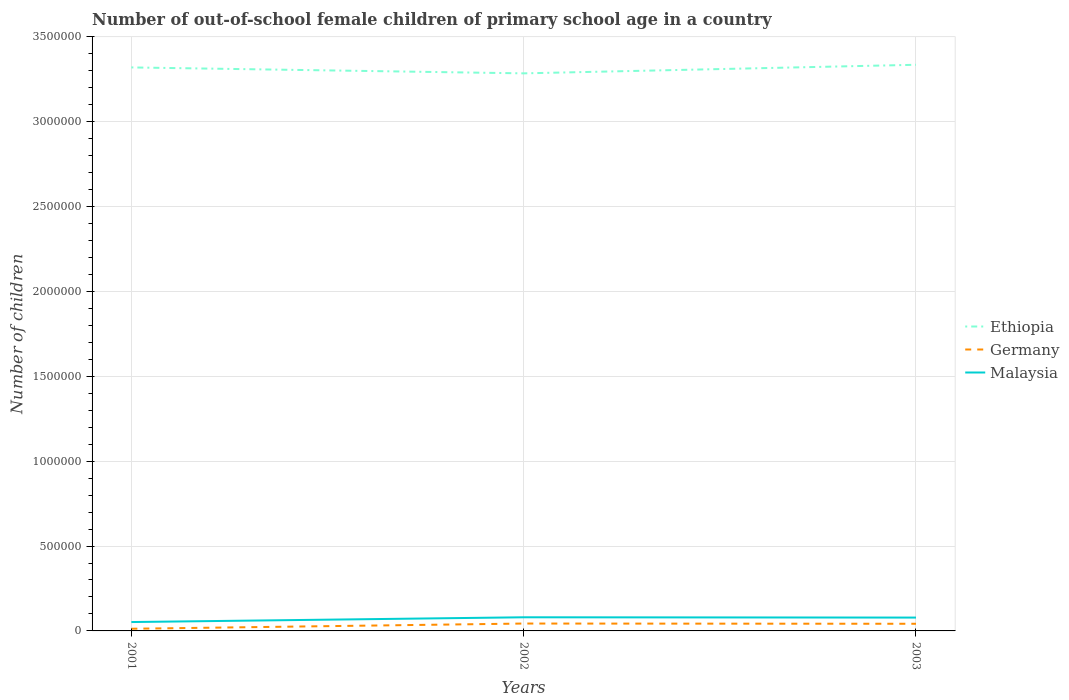How many different coloured lines are there?
Your answer should be compact. 3. Does the line corresponding to Ethiopia intersect with the line corresponding to Germany?
Provide a short and direct response. No. Is the number of lines equal to the number of legend labels?
Your response must be concise. Yes. Across all years, what is the maximum number of out-of-school female children in Germany?
Provide a succinct answer. 1.28e+04. In which year was the number of out-of-school female children in Germany maximum?
Provide a short and direct response. 2001. What is the total number of out-of-school female children in Germany in the graph?
Make the answer very short. 1411. What is the difference between the highest and the second highest number of out-of-school female children in Germany?
Make the answer very short. 3.07e+04. What is the difference between the highest and the lowest number of out-of-school female children in Ethiopia?
Make the answer very short. 2. Is the number of out-of-school female children in Ethiopia strictly greater than the number of out-of-school female children in Malaysia over the years?
Provide a short and direct response. No. Where does the legend appear in the graph?
Your answer should be very brief. Center right. What is the title of the graph?
Offer a very short reply. Number of out-of-school female children of primary school age in a country. What is the label or title of the X-axis?
Offer a very short reply. Years. What is the label or title of the Y-axis?
Your answer should be very brief. Number of children. What is the Number of children in Ethiopia in 2001?
Keep it short and to the point. 3.32e+06. What is the Number of children in Germany in 2001?
Provide a short and direct response. 1.28e+04. What is the Number of children in Malaysia in 2001?
Your answer should be compact. 5.23e+04. What is the Number of children of Ethiopia in 2002?
Provide a short and direct response. 3.28e+06. What is the Number of children in Germany in 2002?
Ensure brevity in your answer.  4.35e+04. What is the Number of children of Malaysia in 2002?
Offer a terse response. 8.04e+04. What is the Number of children of Ethiopia in 2003?
Provide a succinct answer. 3.34e+06. What is the Number of children in Germany in 2003?
Ensure brevity in your answer.  4.21e+04. What is the Number of children of Malaysia in 2003?
Your answer should be compact. 7.86e+04. Across all years, what is the maximum Number of children in Ethiopia?
Provide a succinct answer. 3.34e+06. Across all years, what is the maximum Number of children in Germany?
Your response must be concise. 4.35e+04. Across all years, what is the maximum Number of children in Malaysia?
Offer a very short reply. 8.04e+04. Across all years, what is the minimum Number of children in Ethiopia?
Make the answer very short. 3.28e+06. Across all years, what is the minimum Number of children of Germany?
Keep it short and to the point. 1.28e+04. Across all years, what is the minimum Number of children in Malaysia?
Your answer should be very brief. 5.23e+04. What is the total Number of children of Ethiopia in the graph?
Give a very brief answer. 9.94e+06. What is the total Number of children in Germany in the graph?
Keep it short and to the point. 9.84e+04. What is the total Number of children in Malaysia in the graph?
Offer a terse response. 2.11e+05. What is the difference between the Number of children of Ethiopia in 2001 and that in 2002?
Keep it short and to the point. 3.50e+04. What is the difference between the Number of children of Germany in 2001 and that in 2002?
Ensure brevity in your answer.  -3.07e+04. What is the difference between the Number of children of Malaysia in 2001 and that in 2002?
Your response must be concise. -2.81e+04. What is the difference between the Number of children in Ethiopia in 2001 and that in 2003?
Your answer should be very brief. -1.56e+04. What is the difference between the Number of children in Germany in 2001 and that in 2003?
Your response must be concise. -2.93e+04. What is the difference between the Number of children in Malaysia in 2001 and that in 2003?
Provide a succinct answer. -2.63e+04. What is the difference between the Number of children of Ethiopia in 2002 and that in 2003?
Give a very brief answer. -5.06e+04. What is the difference between the Number of children in Germany in 2002 and that in 2003?
Provide a short and direct response. 1411. What is the difference between the Number of children of Malaysia in 2002 and that in 2003?
Make the answer very short. 1818. What is the difference between the Number of children of Ethiopia in 2001 and the Number of children of Germany in 2002?
Your answer should be compact. 3.28e+06. What is the difference between the Number of children in Ethiopia in 2001 and the Number of children in Malaysia in 2002?
Give a very brief answer. 3.24e+06. What is the difference between the Number of children of Germany in 2001 and the Number of children of Malaysia in 2002?
Provide a succinct answer. -6.76e+04. What is the difference between the Number of children of Ethiopia in 2001 and the Number of children of Germany in 2003?
Ensure brevity in your answer.  3.28e+06. What is the difference between the Number of children of Ethiopia in 2001 and the Number of children of Malaysia in 2003?
Provide a short and direct response. 3.24e+06. What is the difference between the Number of children in Germany in 2001 and the Number of children in Malaysia in 2003?
Your response must be concise. -6.58e+04. What is the difference between the Number of children of Ethiopia in 2002 and the Number of children of Germany in 2003?
Your answer should be very brief. 3.24e+06. What is the difference between the Number of children of Ethiopia in 2002 and the Number of children of Malaysia in 2003?
Offer a very short reply. 3.21e+06. What is the difference between the Number of children in Germany in 2002 and the Number of children in Malaysia in 2003?
Provide a short and direct response. -3.51e+04. What is the average Number of children of Ethiopia per year?
Keep it short and to the point. 3.31e+06. What is the average Number of children in Germany per year?
Your answer should be compact. 3.28e+04. What is the average Number of children of Malaysia per year?
Give a very brief answer. 7.04e+04. In the year 2001, what is the difference between the Number of children of Ethiopia and Number of children of Germany?
Your response must be concise. 3.31e+06. In the year 2001, what is the difference between the Number of children of Ethiopia and Number of children of Malaysia?
Your answer should be very brief. 3.27e+06. In the year 2001, what is the difference between the Number of children in Germany and Number of children in Malaysia?
Provide a short and direct response. -3.95e+04. In the year 2002, what is the difference between the Number of children in Ethiopia and Number of children in Germany?
Give a very brief answer. 3.24e+06. In the year 2002, what is the difference between the Number of children in Ethiopia and Number of children in Malaysia?
Your answer should be very brief. 3.20e+06. In the year 2002, what is the difference between the Number of children in Germany and Number of children in Malaysia?
Your response must be concise. -3.69e+04. In the year 2003, what is the difference between the Number of children of Ethiopia and Number of children of Germany?
Offer a terse response. 3.29e+06. In the year 2003, what is the difference between the Number of children of Ethiopia and Number of children of Malaysia?
Offer a very short reply. 3.26e+06. In the year 2003, what is the difference between the Number of children in Germany and Number of children in Malaysia?
Your answer should be very brief. -3.65e+04. What is the ratio of the Number of children in Ethiopia in 2001 to that in 2002?
Offer a terse response. 1.01. What is the ratio of the Number of children in Germany in 2001 to that in 2002?
Offer a terse response. 0.29. What is the ratio of the Number of children in Malaysia in 2001 to that in 2002?
Your answer should be very brief. 0.65. What is the ratio of the Number of children of Germany in 2001 to that in 2003?
Provide a succinct answer. 0.3. What is the ratio of the Number of children in Malaysia in 2001 to that in 2003?
Keep it short and to the point. 0.67. What is the ratio of the Number of children in Ethiopia in 2002 to that in 2003?
Your answer should be compact. 0.98. What is the ratio of the Number of children in Germany in 2002 to that in 2003?
Ensure brevity in your answer.  1.03. What is the ratio of the Number of children of Malaysia in 2002 to that in 2003?
Offer a terse response. 1.02. What is the difference between the highest and the second highest Number of children in Ethiopia?
Keep it short and to the point. 1.56e+04. What is the difference between the highest and the second highest Number of children of Germany?
Your answer should be compact. 1411. What is the difference between the highest and the second highest Number of children in Malaysia?
Your answer should be compact. 1818. What is the difference between the highest and the lowest Number of children of Ethiopia?
Offer a very short reply. 5.06e+04. What is the difference between the highest and the lowest Number of children of Germany?
Provide a short and direct response. 3.07e+04. What is the difference between the highest and the lowest Number of children in Malaysia?
Your answer should be very brief. 2.81e+04. 